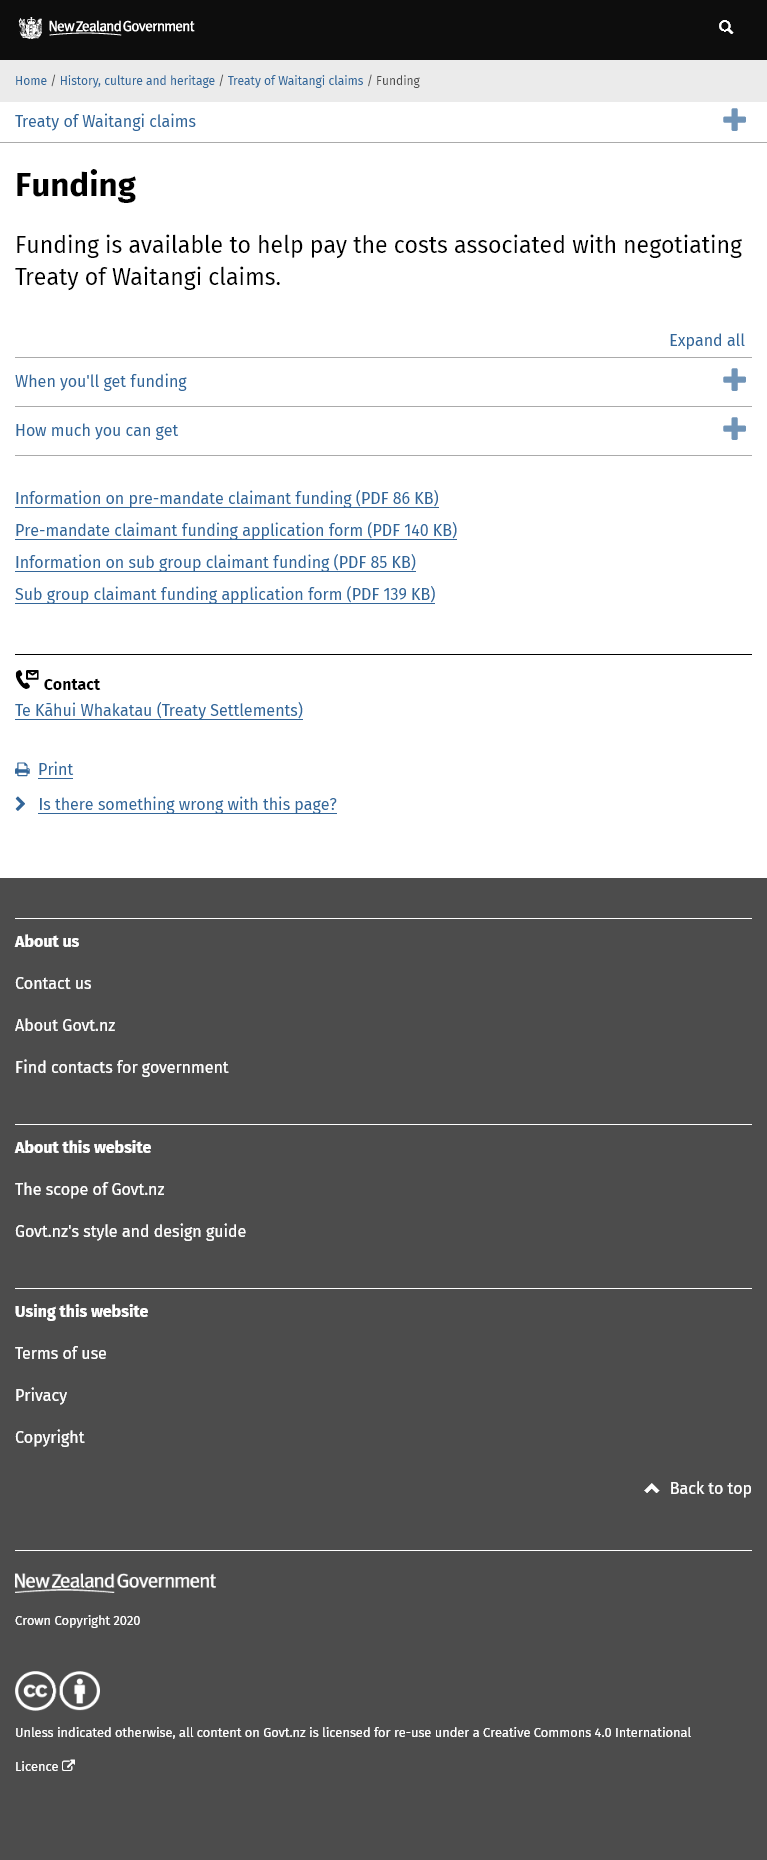Specify some key components in this picture. Yes, there is information on the page regarding the amount that can be claimed towards the costs. Yes, application forms for funding costs associated with Treaty of Waitangi negotiations can be downloaded. They are available on the specified page. I am seeking funding assistance to help cover the costs associated with negotiating Treaty of Waitangi claims, as outlined in the He Kākano: Guide to Crown-Māori Relationships document. 